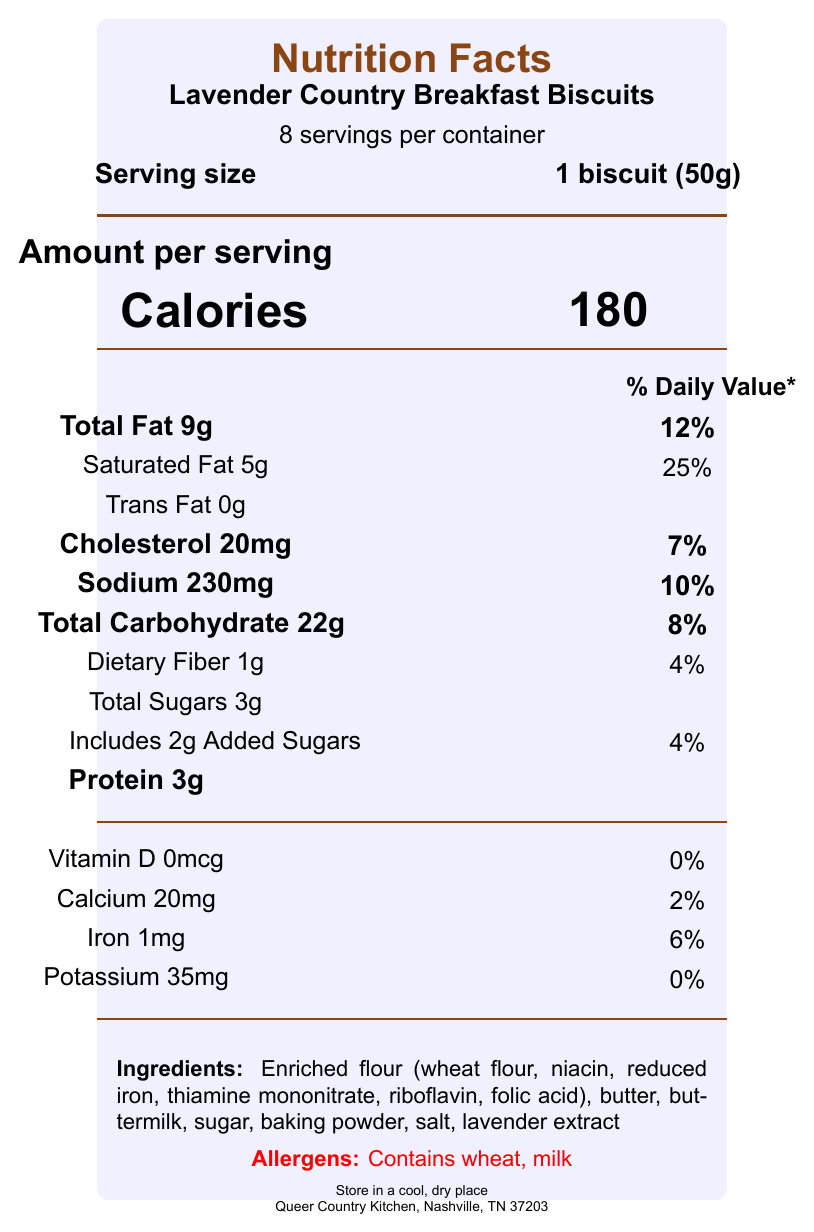What is the serving size for Lavender Country Breakfast Biscuits? The serving size is stated directly in the document as "1 biscuit (50g)".
Answer: 1 biscuit (50g) How many calories are there per serving? The calories per serving are indicated as 180 in the document.
Answer: 180 What percentage of the daily value of saturated fat is in one serving? The document specifies that one serving contains 25% of the daily value for saturated fat.
Answer: 25% What are the main ingredients listed for the Lavender Country Breakfast Biscuits? The main ingredients are listed clearly in the ingredients section of the document.
Answer: Enriched flour (wheat flour, niacin, reduced iron, thiamine mononitrate, riboflavin, folic acid), butter, buttermilk, sugar, baking powder, salt, lavender extract What allergens are present in the Lavender Country Breakfast Biscuits? The allergens are explicitly mentioned in red text as "Contains wheat, milk".
Answer: Wheat, milk How many grams of protein are in each serving? The amount of protein per serving is listed as 3g.
Answer: 3g How much calcium is in one serving of Lavender Country Breakfast Biscuits, and what is its percentage of the daily value? The document lists the calcium content as 20mg, which is 2% of the daily value.
Answer: 20mg, 2% Does one serving of Lavender Country Breakfast Biscuits contain any trans fat? The document states that trans fat content is 0g.
Answer: No Summarize the main information provided in the Nutrition Facts label for Lavender Country Breakfast Biscuits. The explanation details specific values for calories, macronutrients, vitamins, minerals, ingredients, and allergens as mentioned in the document.
Answer: The Nutrition Facts label for Lavender Country Breakfast Biscuits highlights that each serving size is 1 biscuit (50g), with 8 servings per container. Per serving, there are 180 calories, with 9g of total fat (12% DV), 5g of saturated fat (25% DV), 20mg of cholesterol (7% DV), 230mg of sodium (10% DV), 22g of total carbohydrates (8% DV), 1g of dietary fiber (4% DV), 3g of total sugars (including 2g added sugars, 4% DV), and 3g of protein. It also contains small percentages of Calcium (2%), Iron (6%), and Potassium (0%). The ingredients include enriched flour, butter, buttermilk, sugar, baking powder, salt, and lavender extract, and it contains allergens wheat and milk. What is the name of the manufacturer and its location? The manufacturer's name and location are indicated at the bottom of the document.
Answer: Queer Country Kitchen, Nashville, TN 37203 From which band or artist is the inspiration note related to these biscuits mentioned? The fan note mentions that the biscuits are inspired by the groundbreaking artistry of Lavender Country.
Answer: Lavender Country How many servings per container are there for the Lavender Country Breakfast Biscuits? The document states that there are 8 servings per container.
Answer: 8 Is there any information about whether the Lavender Country Breakfast Biscuits contain gluten? While the document lists wheat as an allergen, which commonly contains gluten, the document does not explicitly mention gluten.
Answer: Not enough information 